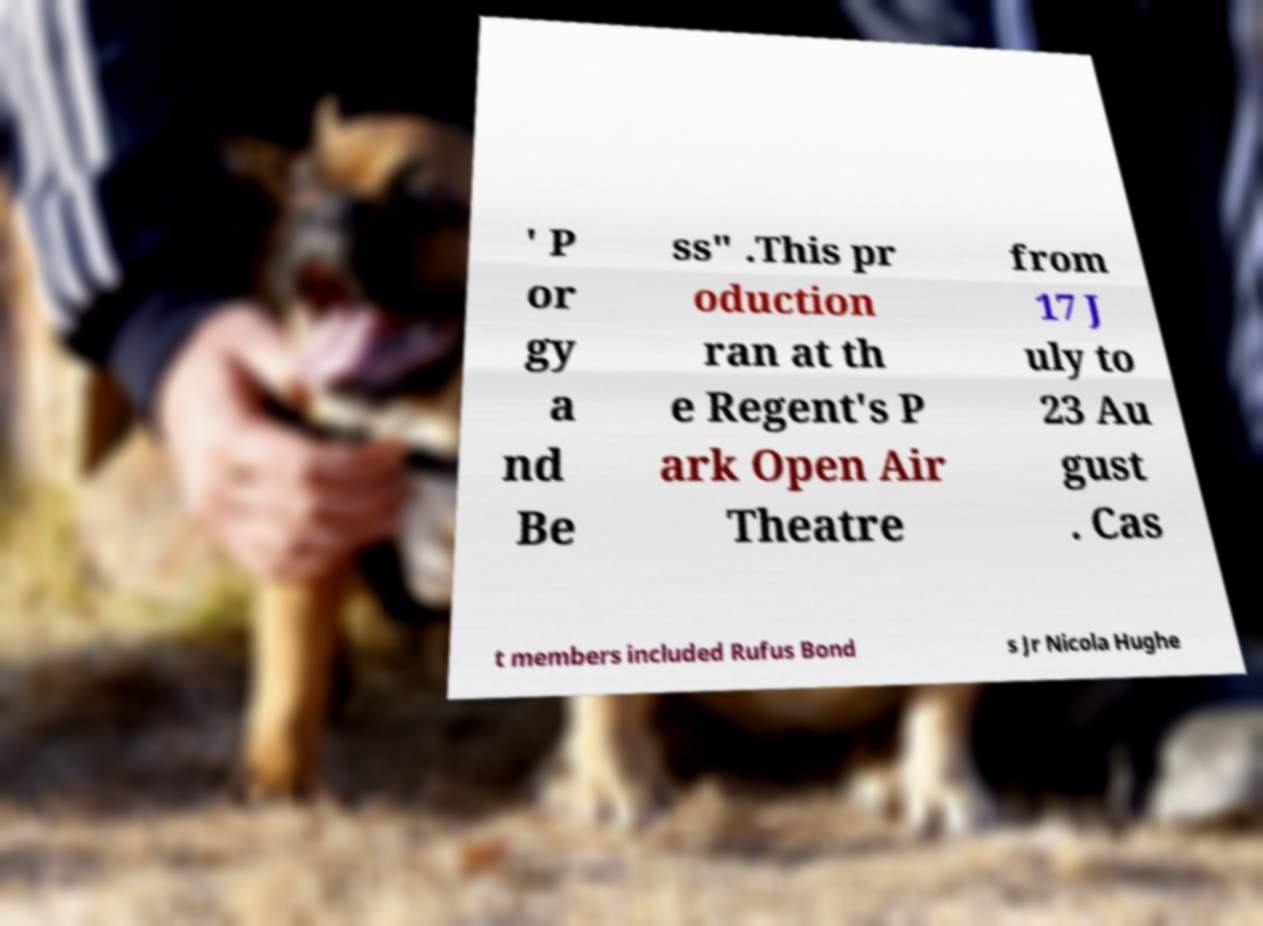Please identify and transcribe the text found in this image. ' P or gy a nd Be ss" .This pr oduction ran at th e Regent's P ark Open Air Theatre from 17 J uly to 23 Au gust . Cas t members included Rufus Bond s Jr Nicola Hughe 